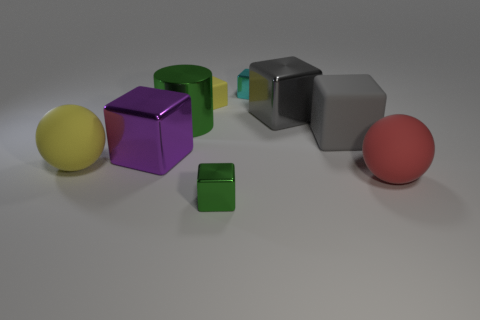What shape is the matte object that is on the right side of the tiny rubber thing and to the left of the red rubber sphere?
Provide a short and direct response. Cube. Are there fewer large green cylinders than large shiny objects?
Make the answer very short. Yes. Is there a big brown matte cube?
Your answer should be very brief. No. How many other objects are there of the same size as the cyan shiny object?
Your answer should be compact. 2. Is the purple block made of the same material as the green object in front of the yellow rubber sphere?
Provide a succinct answer. Yes. Is the number of green cylinders behind the cyan metallic block the same as the number of large purple shiny blocks in front of the green block?
Offer a terse response. Yes. What is the material of the red object?
Ensure brevity in your answer.  Rubber. There is a rubber block that is the same size as the cylinder; what color is it?
Offer a terse response. Gray. There is a small metal thing behind the big yellow matte object; is there a small cyan metallic cube in front of it?
Your answer should be compact. No. What number of balls are either large red rubber objects or cyan things?
Your answer should be very brief. 1. 